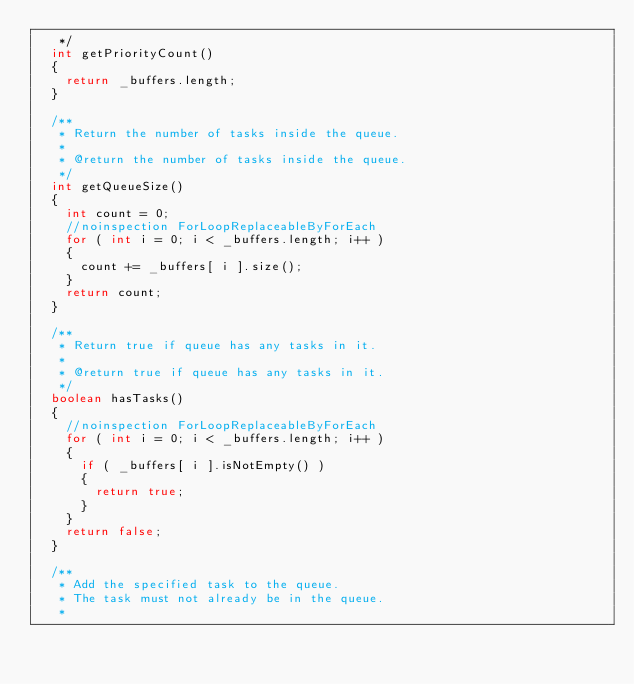Convert code to text. <code><loc_0><loc_0><loc_500><loc_500><_Java_>   */
  int getPriorityCount()
  {
    return _buffers.length;
  }

  /**
   * Return the number of tasks inside the queue.
   *
   * @return the number of tasks inside the queue.
   */
  int getQueueSize()
  {
    int count = 0;
    //noinspection ForLoopReplaceableByForEach
    for ( int i = 0; i < _buffers.length; i++ )
    {
      count += _buffers[ i ].size();
    }
    return count;
  }

  /**
   * Return true if queue has any tasks in it.
   *
   * @return true if queue has any tasks in it.
   */
  boolean hasTasks()
  {
    //noinspection ForLoopReplaceableByForEach
    for ( int i = 0; i < _buffers.length; i++ )
    {
      if ( _buffers[ i ].isNotEmpty() )
      {
        return true;
      }
    }
    return false;
  }

  /**
   * Add the specified task to the queue.
   * The task must not already be in the queue.
   *</code> 